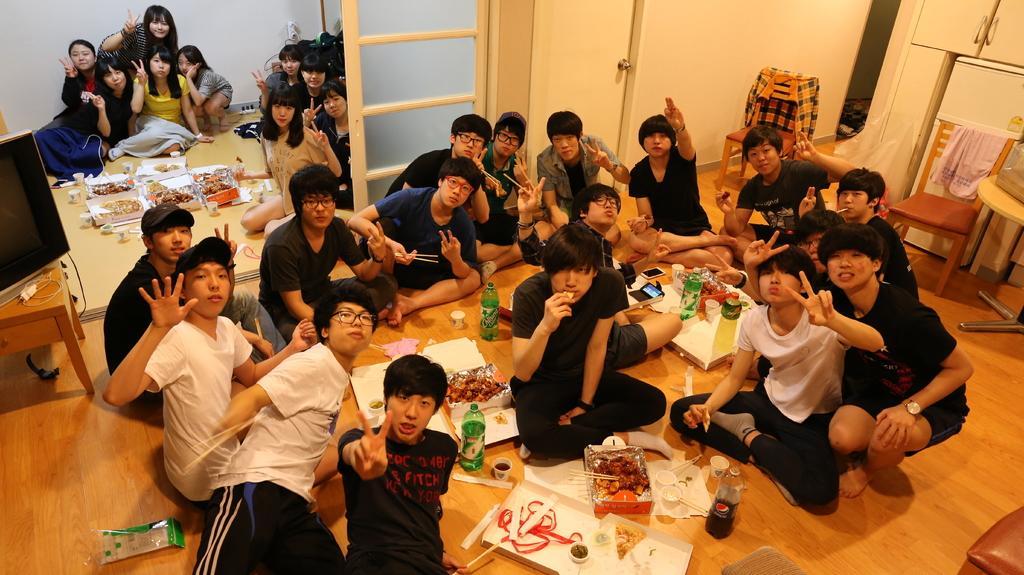Can you describe this image briefly? In this picture there are many people sitting on the floor and eating some food. There are many people in this room. There are women and men. In the background there is a bag and a wall here. 